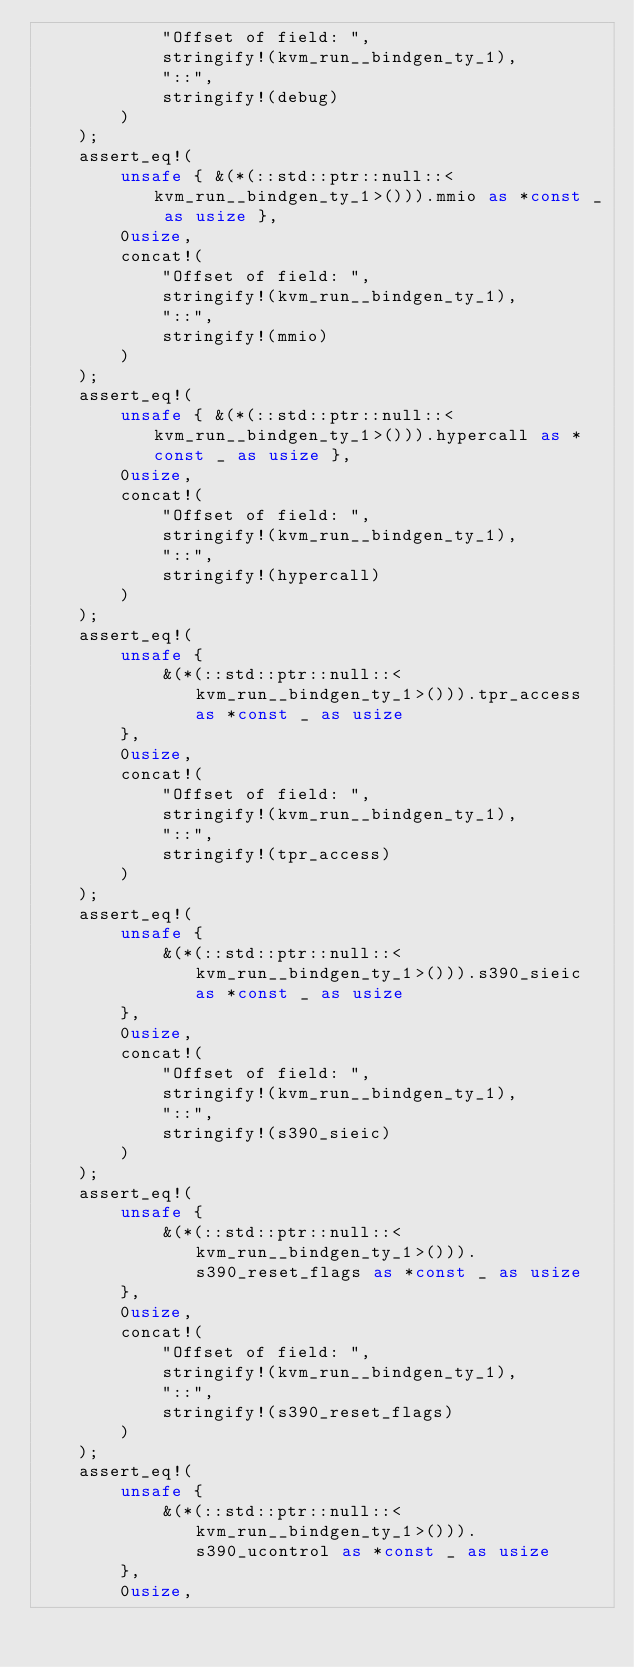<code> <loc_0><loc_0><loc_500><loc_500><_Rust_>            "Offset of field: ",
            stringify!(kvm_run__bindgen_ty_1),
            "::",
            stringify!(debug)
        )
    );
    assert_eq!(
        unsafe { &(*(::std::ptr::null::<kvm_run__bindgen_ty_1>())).mmio as *const _ as usize },
        0usize,
        concat!(
            "Offset of field: ",
            stringify!(kvm_run__bindgen_ty_1),
            "::",
            stringify!(mmio)
        )
    );
    assert_eq!(
        unsafe { &(*(::std::ptr::null::<kvm_run__bindgen_ty_1>())).hypercall as *const _ as usize },
        0usize,
        concat!(
            "Offset of field: ",
            stringify!(kvm_run__bindgen_ty_1),
            "::",
            stringify!(hypercall)
        )
    );
    assert_eq!(
        unsafe {
            &(*(::std::ptr::null::<kvm_run__bindgen_ty_1>())).tpr_access as *const _ as usize
        },
        0usize,
        concat!(
            "Offset of field: ",
            stringify!(kvm_run__bindgen_ty_1),
            "::",
            stringify!(tpr_access)
        )
    );
    assert_eq!(
        unsafe {
            &(*(::std::ptr::null::<kvm_run__bindgen_ty_1>())).s390_sieic as *const _ as usize
        },
        0usize,
        concat!(
            "Offset of field: ",
            stringify!(kvm_run__bindgen_ty_1),
            "::",
            stringify!(s390_sieic)
        )
    );
    assert_eq!(
        unsafe {
            &(*(::std::ptr::null::<kvm_run__bindgen_ty_1>())).s390_reset_flags as *const _ as usize
        },
        0usize,
        concat!(
            "Offset of field: ",
            stringify!(kvm_run__bindgen_ty_1),
            "::",
            stringify!(s390_reset_flags)
        )
    );
    assert_eq!(
        unsafe {
            &(*(::std::ptr::null::<kvm_run__bindgen_ty_1>())).s390_ucontrol as *const _ as usize
        },
        0usize,</code> 